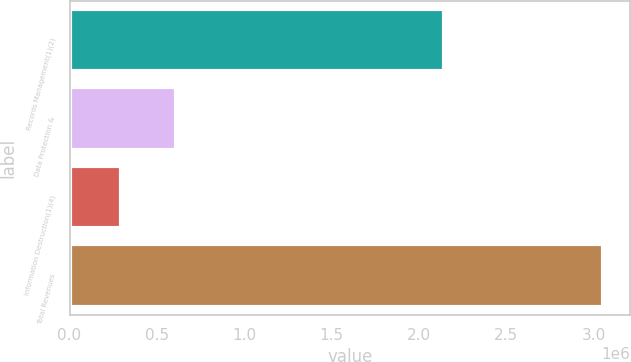<chart> <loc_0><loc_0><loc_500><loc_500><bar_chart><fcel>Records Management(1)(2)<fcel>Data Protection &<fcel>Information Destruction(1)(4)<fcel>Total Revenues<nl><fcel>2.14629e+06<fcel>612158<fcel>296683<fcel>3.05513e+06<nl></chart> 